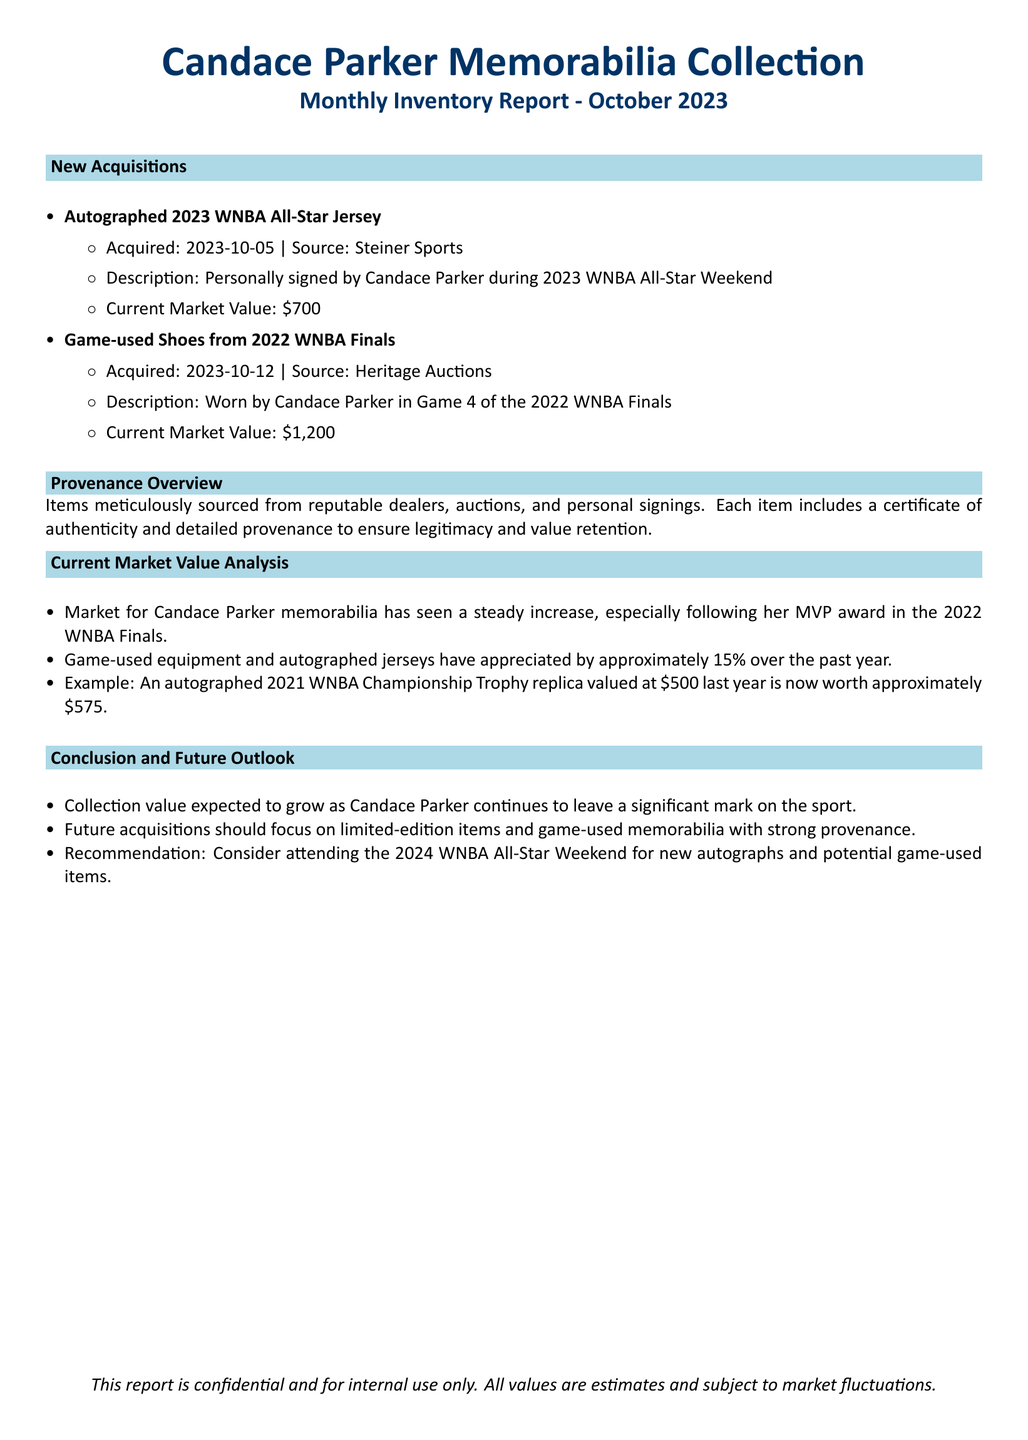What is the title of the report? The title of the report is mentioned at the beginning of the document, which identifies it as a monthly inventory report for October 2023.
Answer: Monthly Inventory Report - October 2023 When was the autographed jersey acquired? The document provides the acquisition date for this item listed under new acquisitions.
Answer: 2023-10-05 What is the current market value of the game-used shoes? The market value is specified in the section detailing new acquisitions of the game-used shoes.
Answer: $1,200 What type of memorabilia is suggested for future acquisitions? The conclusion section of the document advises on future collection strategies for acquiring new items.
Answer: Limited-edition items and game-used memorabilia What was the percentage increase in the value of memorabilia over the past year? The market value analysis discusses the appreciation in value for specific types of memorabilia over the last year.
Answer: 15% Who was the source for the autographed jersey? The document lists the source for this acquisition in the new acquisitions section.
Answer: Steiner Sports What significant event occurred related to Candace Parker in 2022? The market value analysis section notes an event that contributed to the increased market for her memorabilia.
Answer: MVP award in the 2022 WNBA Finals What is included with each item for authentication? The provenance overview section specifies what accompanies the items to ensure their legitimacy.
Answer: Certificate of authenticity 